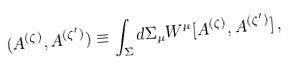<formula> <loc_0><loc_0><loc_500><loc_500>( A ^ { ( \zeta ) } , A ^ { ( \zeta ^ { \prime } ) } ) \equiv \int _ { \Sigma } d \Sigma _ { \mu } W ^ { \mu } [ A ^ { ( \zeta ) } , A ^ { ( \zeta ^ { \prime } ) } ] \, ,</formula> 